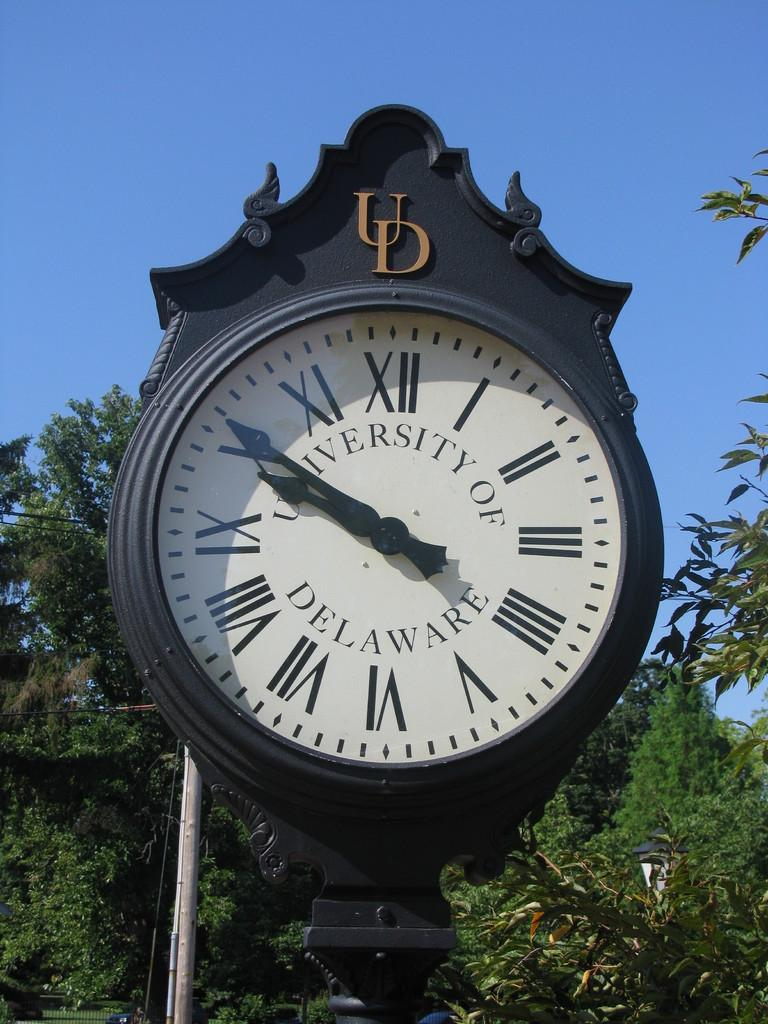<image>
Present a compact description of the photo's key features. An old round antique clock at the University of Delaware 